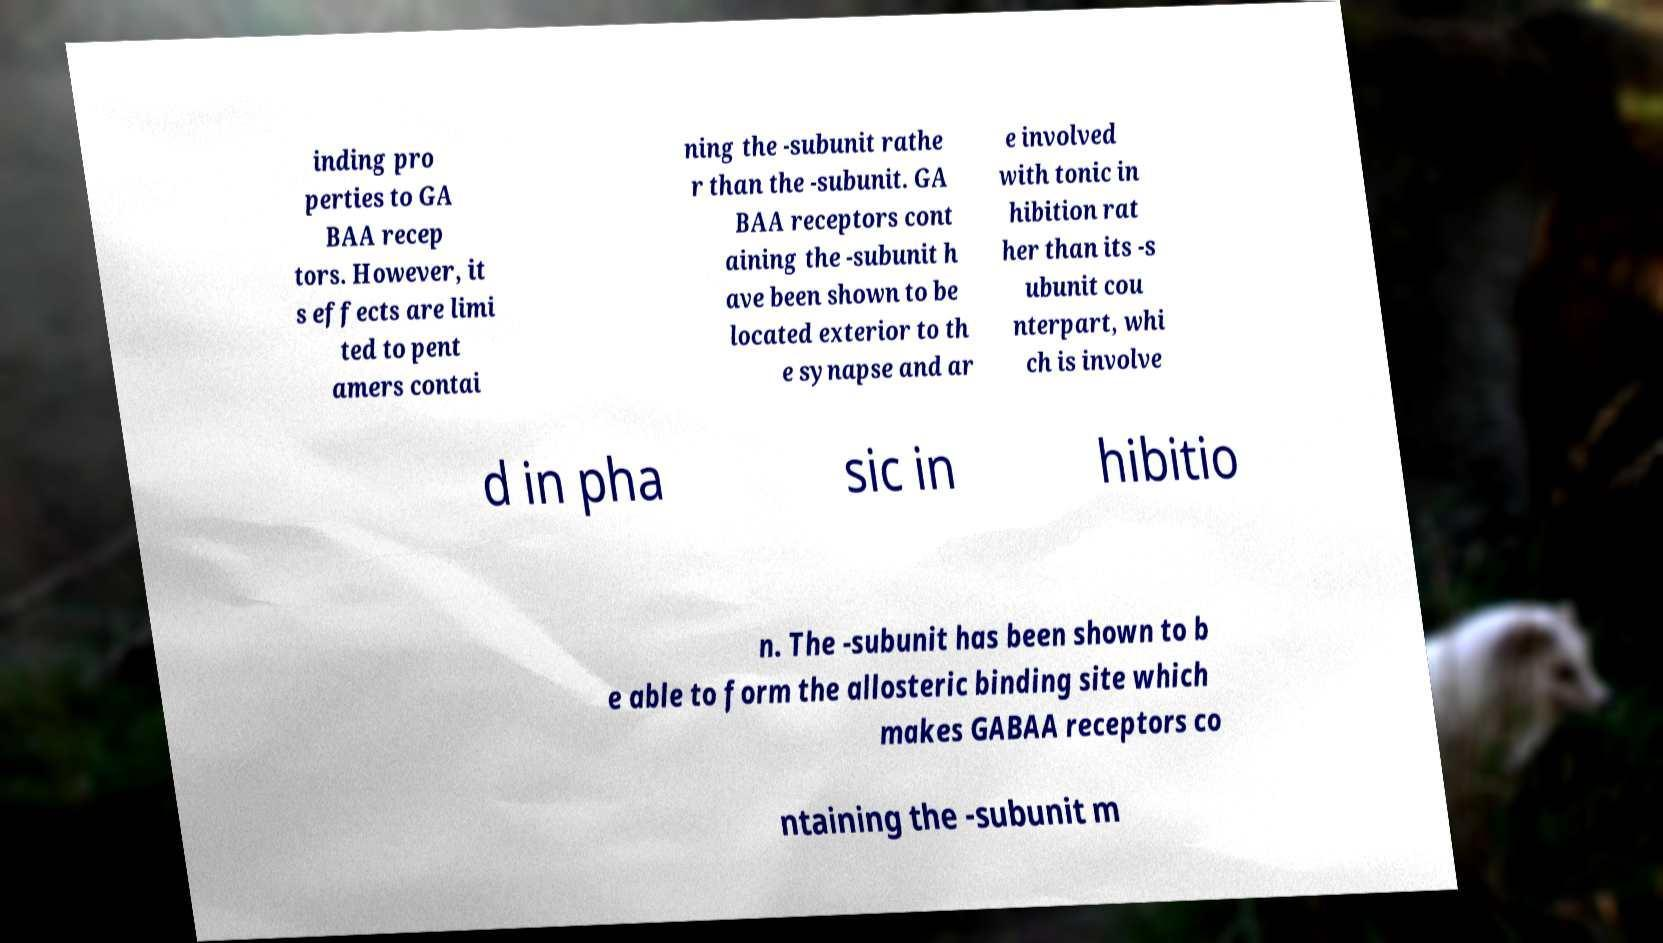Please identify and transcribe the text found in this image. inding pro perties to GA BAA recep tors. However, it s effects are limi ted to pent amers contai ning the -subunit rathe r than the -subunit. GA BAA receptors cont aining the -subunit h ave been shown to be located exterior to th e synapse and ar e involved with tonic in hibition rat her than its -s ubunit cou nterpart, whi ch is involve d in pha sic in hibitio n. The -subunit has been shown to b e able to form the allosteric binding site which makes GABAA receptors co ntaining the -subunit m 